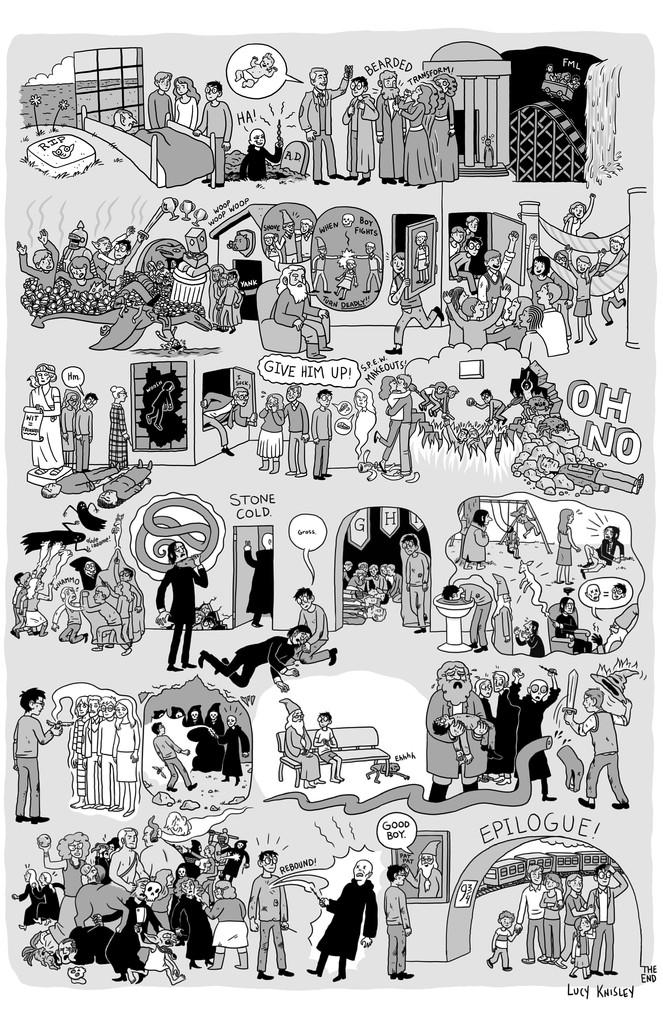Can you describe the main subject or object in the image? Unfortunately, there is not enough specific information provided to identify the main subject or object in the image. What type of knowledge is being shared by the plant in the image? There is no plant present in the image, and therefore no knowledge can be shared by a plant. 